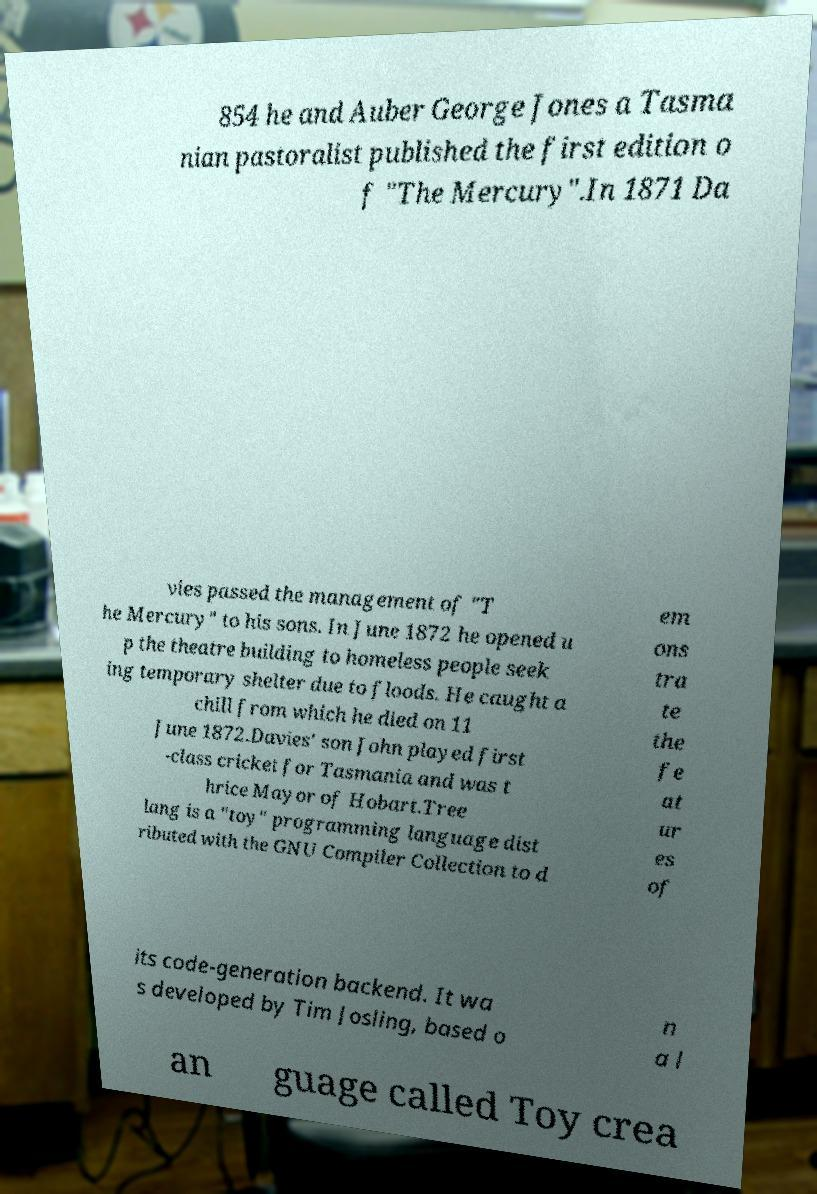For documentation purposes, I need the text within this image transcribed. Could you provide that? 854 he and Auber George Jones a Tasma nian pastoralist published the first edition o f "The Mercury".In 1871 Da vies passed the management of "T he Mercury" to his sons. In June 1872 he opened u p the theatre building to homeless people seek ing temporary shelter due to floods. He caught a chill from which he died on 11 June 1872.Davies' son John played first -class cricket for Tasmania and was t hrice Mayor of Hobart.Tree lang is a "toy" programming language dist ributed with the GNU Compiler Collection to d em ons tra te the fe at ur es of its code-generation backend. It wa s developed by Tim Josling, based o n a l an guage called Toy crea 